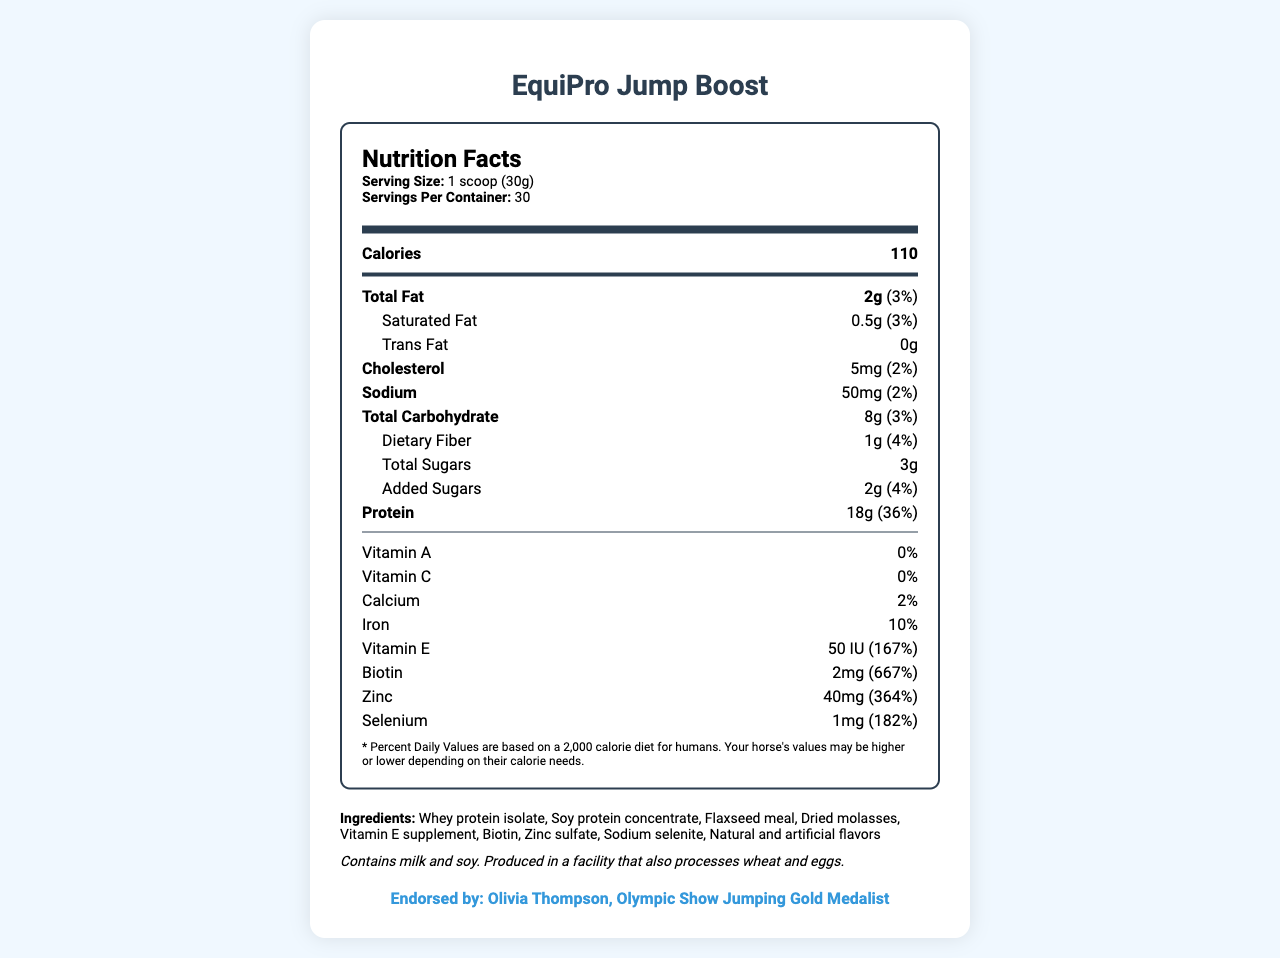what is the serving size for EquiPro Jump Boost? The document specifies at the beginning of the nutrition label under the serving information: "Serving Size: 1 scoop (30g)".
Answer: 1 scoop (30g) how many servings are there per container of EquiPro Jump Boost? The number of servings per container is listed below the serving size information: "Servings Per Container: 30".
Answer: 30 how much protein does one serving of EquiPro Jump Boost contain? Under the nutrition facts, the protein content is listed as "Protein: 18g (36%)".
Answer: 18g what is the daily value percentage of Vitamin E in EquiPro Jump Boost? The daily value percentage for Vitamin E is listed as "Vitamin E: 50 IU (167%)".
Answer: 167% List three main ingredients in EquiPro Jump Boost? The ingredients are listed at the bottom of the document and include "Whey protein isolate, Soy protein concentrate, Flaxseed meal".
Answer: Whey protein isolate, Soy protein concentrate, Flaxseed meal how much total fat is in one serving of EquiPro Jump Boost? A. 1g B. 2g C. 3g D. 4g The total fat content is listed as "Total Fat: 2g (3%)".
Answer: B What is the amount of cholesterol present in one serving of EquiPro Jump Boost? 1. 5mg  2. 10mg  3. 15mg The cholesterol content is indicated as "Cholesterol: 5mg (2%)".
Answer: 1. 5mg Is there any trans fat in EquiPro Jump Boost? The nutrition facts indicate "Trans Fat: 0g".
Answer: No Does EquiPro Jump Boost contain any Vitamin C? The document states "Vitamin C: 0%".
Answer: No what makes EquiPro Jump Boost unique for competitive show jumping horses? The supplement is designed to support muscle development and recovery, and it is endorsed by Olivia Thompson, an Olympic Show Jumping Gold Medalist, which is mentioned in the product description and the endorsement details at the end.
Answer: High-protein supplement for muscle development and recovery. Endorsed by top riders. What are the allergens present in EquiPro Jump Boost? The allergen info section states: "Contains milk and soy."
Answer: Milk and soy What is the suggested storage method for EquiPro Jump Boost? The storage instructions are listed at the bottom of the document: "Store in a cool, dry place. Reseal bag after each use."
Answer: Store in a cool, dry place. Reseal bag after each use. Is this supplement suitable for horses with wheat allergies? The document says it is produced in a facility that also processes wheat, but doesn't explicitly state if it contains wheat or is safe for horses with wheat allergies.
Answer: Cannot be determined What are the total calories in 2 servings of EquiPro Jump Boost? One serving contains 110 calories, so 2 servings contain 110 * 2 = 220 calories.
Answer: 220 calories Summarize the main purpose and components of EquiPro Jump Boost. The main purpose of the supplement is to aid in muscle development and recovery for show jumping horses. Key components include protein, vitamins, and minerals, with endorsements from a top rider. The supplement has clear feeding and storage instructions, and it contains certain allergens.
Answer: EquiPro Jump Boost is a high-protein supplement designed to support muscle development and recovery in competitive show jumping horses. It provides essential nutrients like protein, vitamins, and minerals, and is endorsed by Olympic Show Jumping Gold Medalist, Olivia Thompson. The product has specific feeding instructions and storage guidelines and contains allergens like milk and soy. 